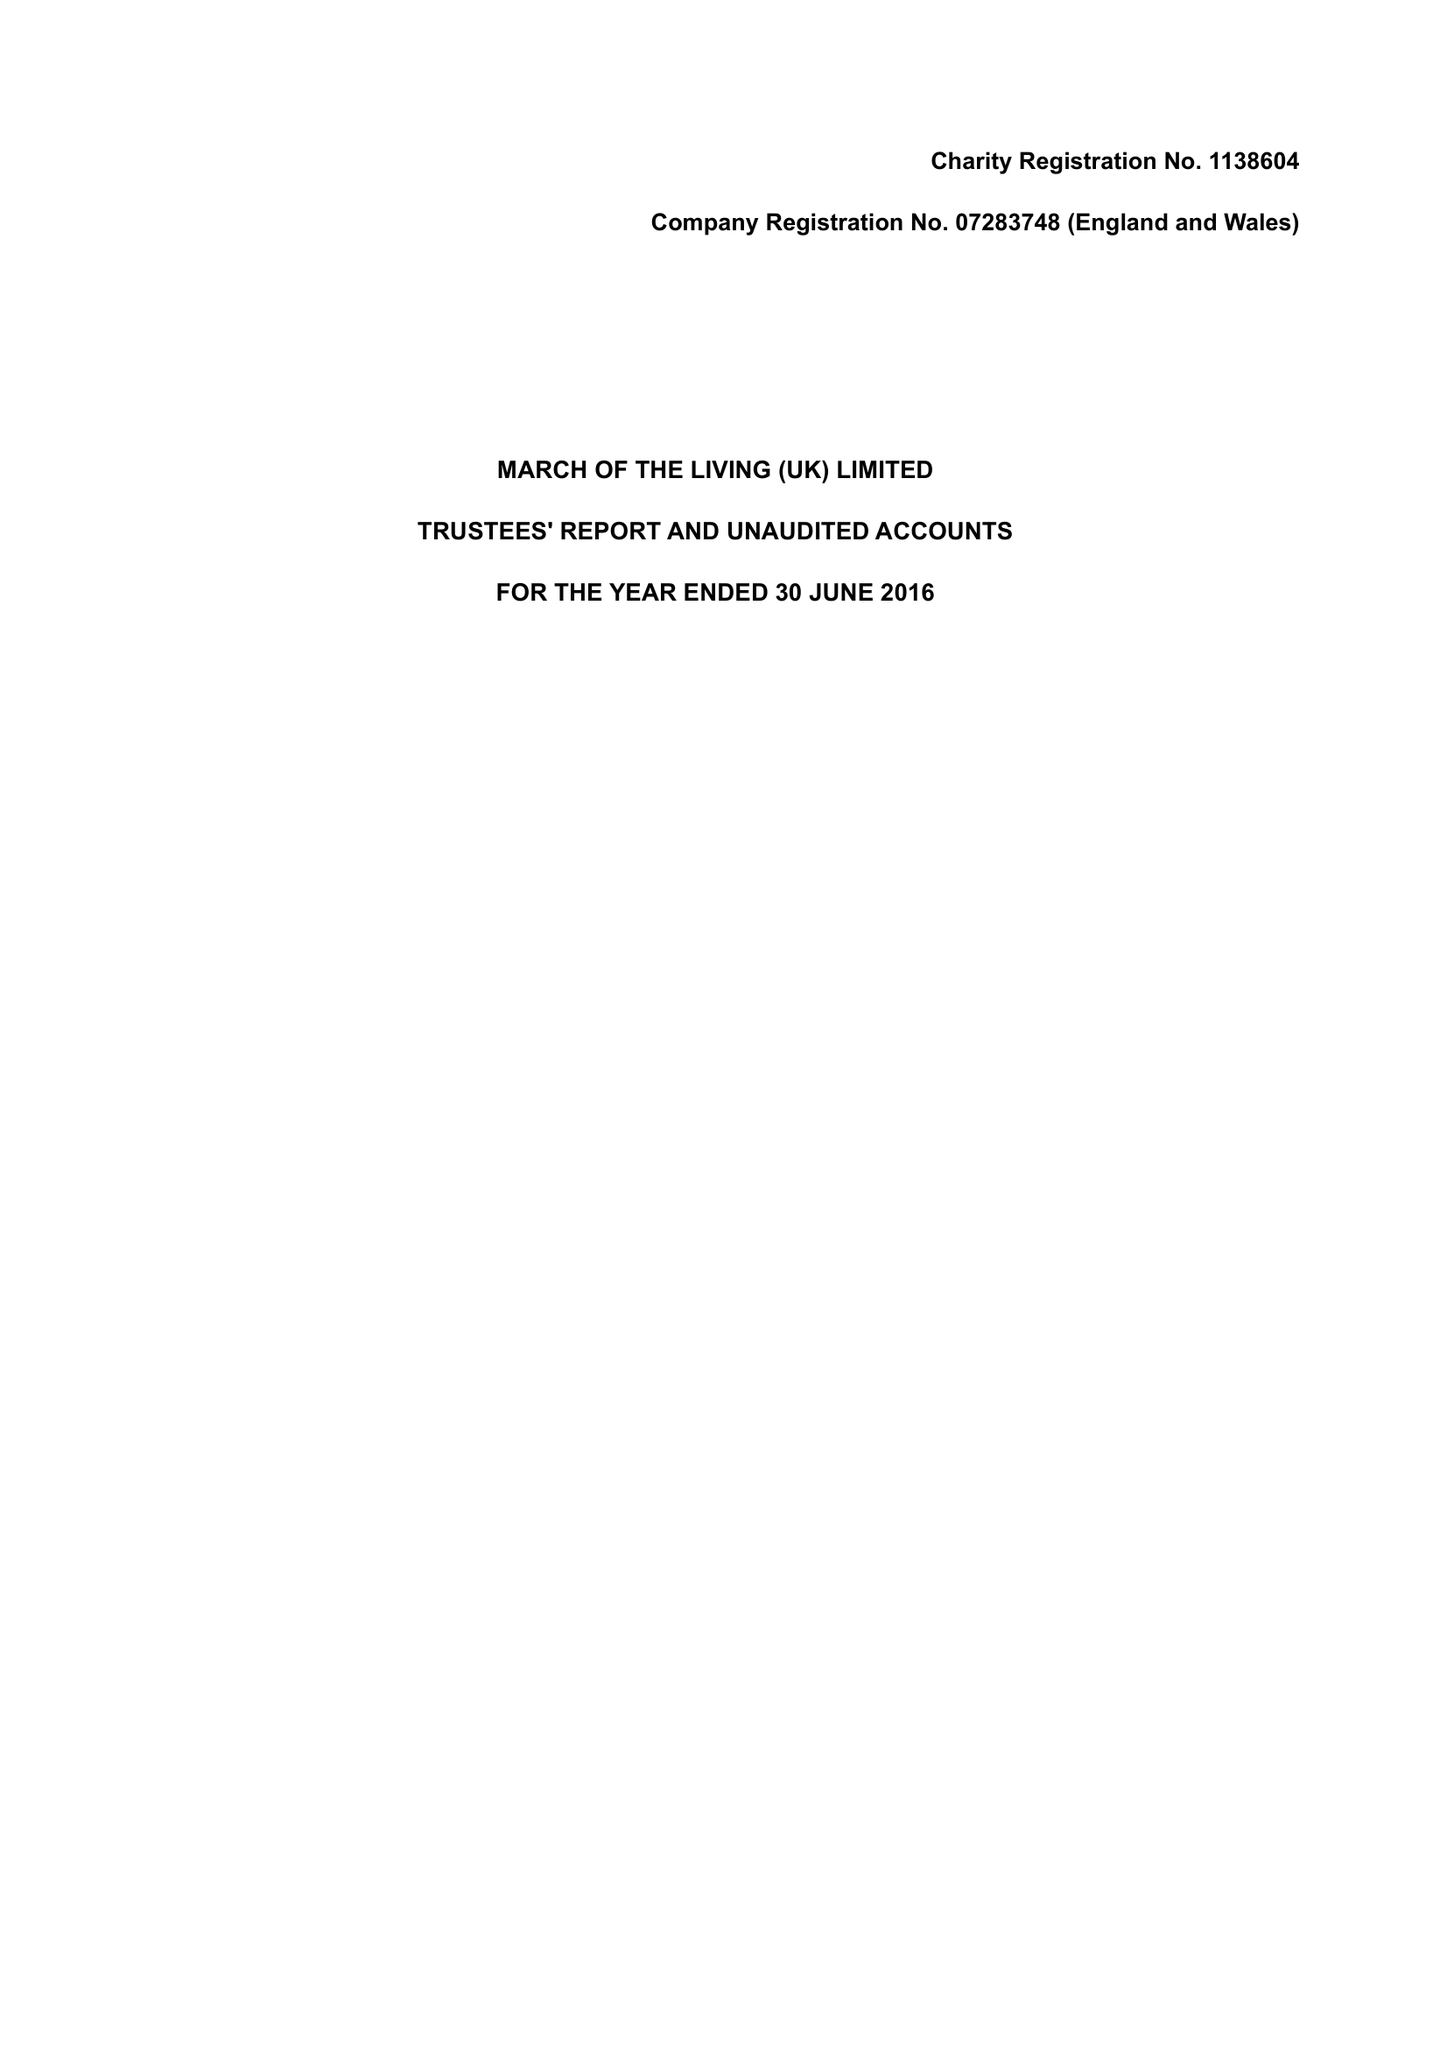What is the value for the income_annually_in_british_pounds?
Answer the question using a single word or phrase. 315128.00 